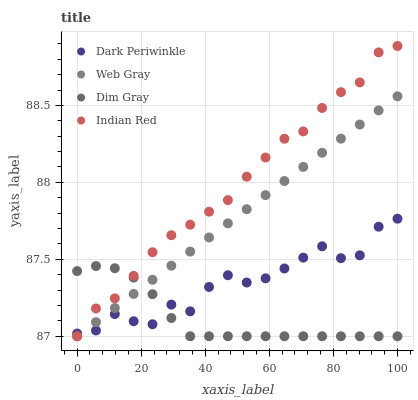Does Dim Gray have the minimum area under the curve?
Answer yes or no. Yes. Does Indian Red have the maximum area under the curve?
Answer yes or no. Yes. Does Web Gray have the minimum area under the curve?
Answer yes or no. No. Does Web Gray have the maximum area under the curve?
Answer yes or no. No. Is Web Gray the smoothest?
Answer yes or no. Yes. Is Dark Periwinkle the roughest?
Answer yes or no. Yes. Is Dark Periwinkle the smoothest?
Answer yes or no. No. Is Web Gray the roughest?
Answer yes or no. No. Does Dim Gray have the lowest value?
Answer yes or no. Yes. Does Dark Periwinkle have the lowest value?
Answer yes or no. No. Does Indian Red have the highest value?
Answer yes or no. Yes. Does Web Gray have the highest value?
Answer yes or no. No. Does Indian Red intersect Web Gray?
Answer yes or no. Yes. Is Indian Red less than Web Gray?
Answer yes or no. No. Is Indian Red greater than Web Gray?
Answer yes or no. No. 